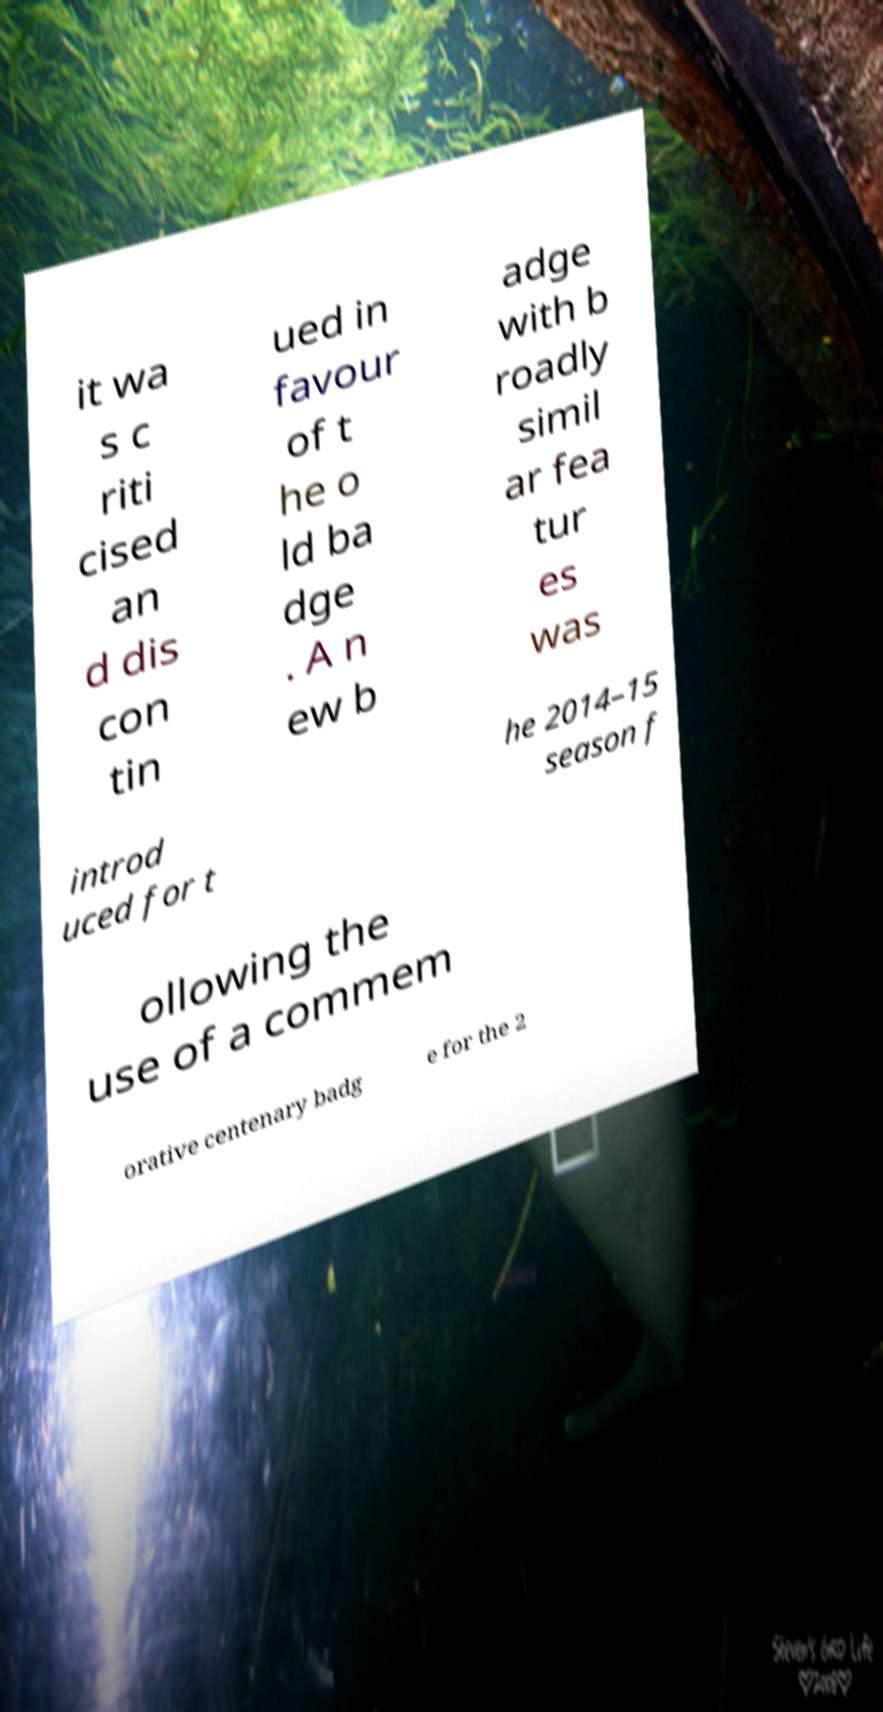For documentation purposes, I need the text within this image transcribed. Could you provide that? it wa s c riti cised an d dis con tin ued in favour of t he o ld ba dge . A n ew b adge with b roadly simil ar fea tur es was introd uced for t he 2014–15 season f ollowing the use of a commem orative centenary badg e for the 2 